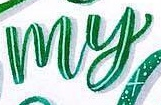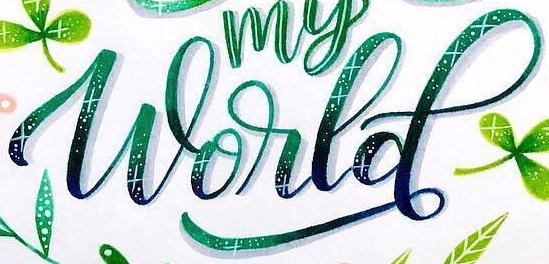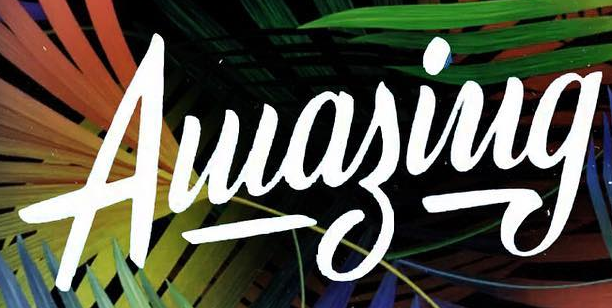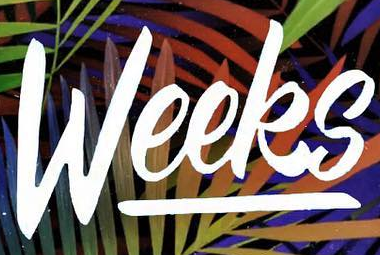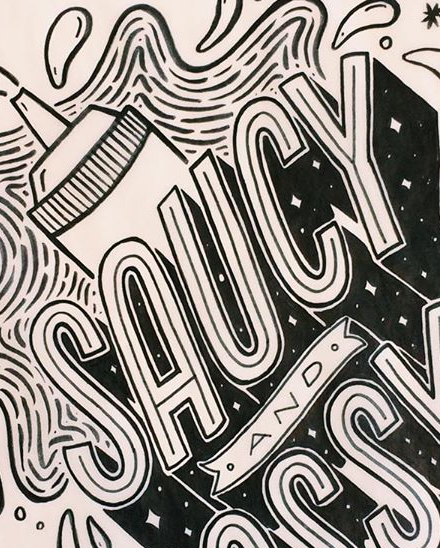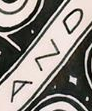What words are shown in these images in order, separated by a semicolon? my; World; Aluagiug; Weeks; SAUCY; AND 